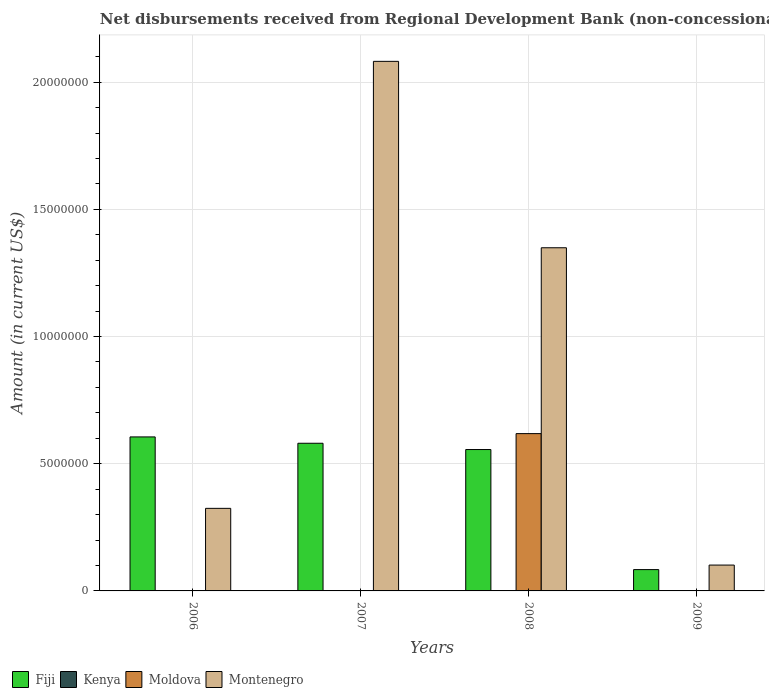How many different coloured bars are there?
Offer a terse response. 3. How many groups of bars are there?
Provide a short and direct response. 4. Are the number of bars per tick equal to the number of legend labels?
Provide a short and direct response. No. How many bars are there on the 2nd tick from the left?
Your answer should be very brief. 2. What is the label of the 4th group of bars from the left?
Offer a terse response. 2009. What is the amount of disbursements received from Regional Development Bank in Fiji in 2008?
Provide a short and direct response. 5.56e+06. Across all years, what is the maximum amount of disbursements received from Regional Development Bank in Fiji?
Offer a very short reply. 6.05e+06. What is the total amount of disbursements received from Regional Development Bank in Montenegro in the graph?
Offer a terse response. 3.86e+07. What is the difference between the amount of disbursements received from Regional Development Bank in Montenegro in 2006 and that in 2008?
Provide a short and direct response. -1.02e+07. What is the difference between the amount of disbursements received from Regional Development Bank in Kenya in 2007 and the amount of disbursements received from Regional Development Bank in Fiji in 2008?
Your response must be concise. -5.56e+06. In the year 2008, what is the difference between the amount of disbursements received from Regional Development Bank in Fiji and amount of disbursements received from Regional Development Bank in Montenegro?
Offer a very short reply. -7.93e+06. In how many years, is the amount of disbursements received from Regional Development Bank in Fiji greater than 5000000 US$?
Your response must be concise. 3. What is the ratio of the amount of disbursements received from Regional Development Bank in Fiji in 2006 to that in 2007?
Offer a terse response. 1.04. Is the amount of disbursements received from Regional Development Bank in Montenegro in 2007 less than that in 2009?
Give a very brief answer. No. What is the difference between the highest and the second highest amount of disbursements received from Regional Development Bank in Fiji?
Provide a short and direct response. 2.49e+05. What is the difference between the highest and the lowest amount of disbursements received from Regional Development Bank in Montenegro?
Make the answer very short. 1.98e+07. Is it the case that in every year, the sum of the amount of disbursements received from Regional Development Bank in Moldova and amount of disbursements received from Regional Development Bank in Montenegro is greater than the sum of amount of disbursements received from Regional Development Bank in Fiji and amount of disbursements received from Regional Development Bank in Kenya?
Your answer should be compact. No. Is it the case that in every year, the sum of the amount of disbursements received from Regional Development Bank in Fiji and amount of disbursements received from Regional Development Bank in Moldova is greater than the amount of disbursements received from Regional Development Bank in Montenegro?
Give a very brief answer. No. Are all the bars in the graph horizontal?
Offer a terse response. No. Does the graph contain grids?
Provide a short and direct response. Yes. What is the title of the graph?
Your response must be concise. Net disbursements received from Regional Development Bank (non-concessional). Does "Kyrgyz Republic" appear as one of the legend labels in the graph?
Your answer should be very brief. No. What is the label or title of the X-axis?
Your response must be concise. Years. What is the label or title of the Y-axis?
Your answer should be very brief. Amount (in current US$). What is the Amount (in current US$) in Fiji in 2006?
Your answer should be very brief. 6.05e+06. What is the Amount (in current US$) of Kenya in 2006?
Provide a succinct answer. 0. What is the Amount (in current US$) of Moldova in 2006?
Keep it short and to the point. 0. What is the Amount (in current US$) in Montenegro in 2006?
Provide a succinct answer. 3.25e+06. What is the Amount (in current US$) of Fiji in 2007?
Make the answer very short. 5.80e+06. What is the Amount (in current US$) of Kenya in 2007?
Give a very brief answer. 0. What is the Amount (in current US$) in Montenegro in 2007?
Give a very brief answer. 2.08e+07. What is the Amount (in current US$) in Fiji in 2008?
Keep it short and to the point. 5.56e+06. What is the Amount (in current US$) of Moldova in 2008?
Provide a succinct answer. 6.18e+06. What is the Amount (in current US$) in Montenegro in 2008?
Make the answer very short. 1.35e+07. What is the Amount (in current US$) of Fiji in 2009?
Your answer should be compact. 8.38e+05. What is the Amount (in current US$) of Montenegro in 2009?
Provide a short and direct response. 1.02e+06. Across all years, what is the maximum Amount (in current US$) in Fiji?
Provide a succinct answer. 6.05e+06. Across all years, what is the maximum Amount (in current US$) of Moldova?
Your response must be concise. 6.18e+06. Across all years, what is the maximum Amount (in current US$) in Montenegro?
Your response must be concise. 2.08e+07. Across all years, what is the minimum Amount (in current US$) of Fiji?
Offer a very short reply. 8.38e+05. Across all years, what is the minimum Amount (in current US$) in Moldova?
Provide a short and direct response. 0. Across all years, what is the minimum Amount (in current US$) in Montenegro?
Give a very brief answer. 1.02e+06. What is the total Amount (in current US$) of Fiji in the graph?
Offer a terse response. 1.83e+07. What is the total Amount (in current US$) in Kenya in the graph?
Your answer should be compact. 0. What is the total Amount (in current US$) of Moldova in the graph?
Offer a very short reply. 6.18e+06. What is the total Amount (in current US$) in Montenegro in the graph?
Make the answer very short. 3.86e+07. What is the difference between the Amount (in current US$) of Fiji in 2006 and that in 2007?
Offer a very short reply. 2.49e+05. What is the difference between the Amount (in current US$) of Montenegro in 2006 and that in 2007?
Provide a short and direct response. -1.76e+07. What is the difference between the Amount (in current US$) of Fiji in 2006 and that in 2008?
Give a very brief answer. 4.96e+05. What is the difference between the Amount (in current US$) in Montenegro in 2006 and that in 2008?
Provide a succinct answer. -1.02e+07. What is the difference between the Amount (in current US$) of Fiji in 2006 and that in 2009?
Offer a terse response. 5.22e+06. What is the difference between the Amount (in current US$) in Montenegro in 2006 and that in 2009?
Ensure brevity in your answer.  2.23e+06. What is the difference between the Amount (in current US$) of Fiji in 2007 and that in 2008?
Your answer should be very brief. 2.47e+05. What is the difference between the Amount (in current US$) in Montenegro in 2007 and that in 2008?
Your response must be concise. 7.33e+06. What is the difference between the Amount (in current US$) in Fiji in 2007 and that in 2009?
Keep it short and to the point. 4.97e+06. What is the difference between the Amount (in current US$) of Montenegro in 2007 and that in 2009?
Ensure brevity in your answer.  1.98e+07. What is the difference between the Amount (in current US$) of Fiji in 2008 and that in 2009?
Keep it short and to the point. 4.72e+06. What is the difference between the Amount (in current US$) of Montenegro in 2008 and that in 2009?
Provide a succinct answer. 1.25e+07. What is the difference between the Amount (in current US$) of Fiji in 2006 and the Amount (in current US$) of Montenegro in 2007?
Your response must be concise. -1.48e+07. What is the difference between the Amount (in current US$) in Fiji in 2006 and the Amount (in current US$) in Moldova in 2008?
Make the answer very short. -1.30e+05. What is the difference between the Amount (in current US$) of Fiji in 2006 and the Amount (in current US$) of Montenegro in 2008?
Give a very brief answer. -7.44e+06. What is the difference between the Amount (in current US$) in Fiji in 2006 and the Amount (in current US$) in Montenegro in 2009?
Ensure brevity in your answer.  5.04e+06. What is the difference between the Amount (in current US$) in Fiji in 2007 and the Amount (in current US$) in Moldova in 2008?
Your response must be concise. -3.79e+05. What is the difference between the Amount (in current US$) of Fiji in 2007 and the Amount (in current US$) of Montenegro in 2008?
Your response must be concise. -7.68e+06. What is the difference between the Amount (in current US$) of Fiji in 2007 and the Amount (in current US$) of Montenegro in 2009?
Provide a short and direct response. 4.79e+06. What is the difference between the Amount (in current US$) of Fiji in 2008 and the Amount (in current US$) of Montenegro in 2009?
Keep it short and to the point. 4.54e+06. What is the difference between the Amount (in current US$) of Moldova in 2008 and the Amount (in current US$) of Montenegro in 2009?
Your answer should be very brief. 5.17e+06. What is the average Amount (in current US$) in Fiji per year?
Offer a very short reply. 4.56e+06. What is the average Amount (in current US$) in Moldova per year?
Make the answer very short. 1.55e+06. What is the average Amount (in current US$) in Montenegro per year?
Provide a short and direct response. 9.64e+06. In the year 2006, what is the difference between the Amount (in current US$) of Fiji and Amount (in current US$) of Montenegro?
Offer a very short reply. 2.81e+06. In the year 2007, what is the difference between the Amount (in current US$) in Fiji and Amount (in current US$) in Montenegro?
Provide a short and direct response. -1.50e+07. In the year 2008, what is the difference between the Amount (in current US$) of Fiji and Amount (in current US$) of Moldova?
Make the answer very short. -6.26e+05. In the year 2008, what is the difference between the Amount (in current US$) of Fiji and Amount (in current US$) of Montenegro?
Your answer should be compact. -7.93e+06. In the year 2008, what is the difference between the Amount (in current US$) in Moldova and Amount (in current US$) in Montenegro?
Make the answer very short. -7.31e+06. In the year 2009, what is the difference between the Amount (in current US$) in Fiji and Amount (in current US$) in Montenegro?
Give a very brief answer. -1.78e+05. What is the ratio of the Amount (in current US$) of Fiji in 2006 to that in 2007?
Your answer should be compact. 1.04. What is the ratio of the Amount (in current US$) of Montenegro in 2006 to that in 2007?
Offer a very short reply. 0.16. What is the ratio of the Amount (in current US$) in Fiji in 2006 to that in 2008?
Provide a short and direct response. 1.09. What is the ratio of the Amount (in current US$) in Montenegro in 2006 to that in 2008?
Ensure brevity in your answer.  0.24. What is the ratio of the Amount (in current US$) in Fiji in 2006 to that in 2009?
Provide a short and direct response. 7.22. What is the ratio of the Amount (in current US$) of Montenegro in 2006 to that in 2009?
Your answer should be very brief. 3.19. What is the ratio of the Amount (in current US$) of Fiji in 2007 to that in 2008?
Ensure brevity in your answer.  1.04. What is the ratio of the Amount (in current US$) in Montenegro in 2007 to that in 2008?
Keep it short and to the point. 1.54. What is the ratio of the Amount (in current US$) in Fiji in 2007 to that in 2009?
Offer a terse response. 6.93. What is the ratio of the Amount (in current US$) in Montenegro in 2007 to that in 2009?
Offer a terse response. 20.49. What is the ratio of the Amount (in current US$) in Fiji in 2008 to that in 2009?
Your response must be concise. 6.63. What is the ratio of the Amount (in current US$) of Montenegro in 2008 to that in 2009?
Provide a short and direct response. 13.28. What is the difference between the highest and the second highest Amount (in current US$) in Fiji?
Offer a terse response. 2.49e+05. What is the difference between the highest and the second highest Amount (in current US$) in Montenegro?
Give a very brief answer. 7.33e+06. What is the difference between the highest and the lowest Amount (in current US$) in Fiji?
Keep it short and to the point. 5.22e+06. What is the difference between the highest and the lowest Amount (in current US$) of Moldova?
Offer a terse response. 6.18e+06. What is the difference between the highest and the lowest Amount (in current US$) of Montenegro?
Your answer should be very brief. 1.98e+07. 